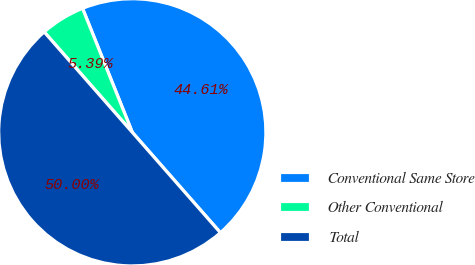<chart> <loc_0><loc_0><loc_500><loc_500><pie_chart><fcel>Conventional Same Store<fcel>Other Conventional<fcel>Total<nl><fcel>44.61%<fcel>5.39%<fcel>50.0%<nl></chart> 